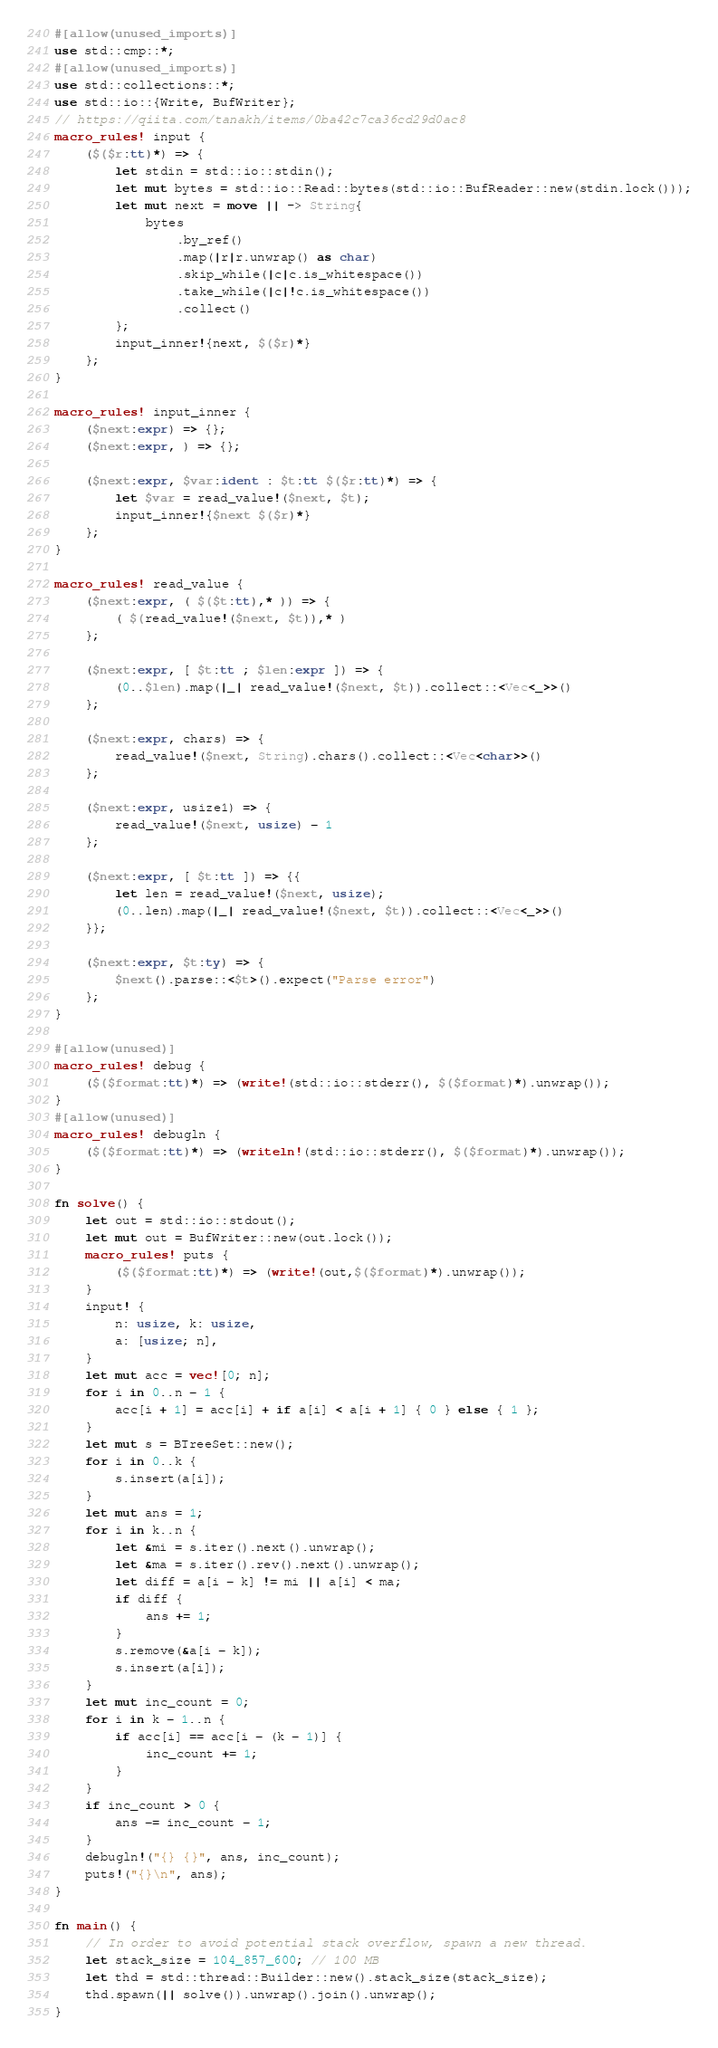Convert code to text. <code><loc_0><loc_0><loc_500><loc_500><_Rust_>#[allow(unused_imports)]
use std::cmp::*;
#[allow(unused_imports)]
use std::collections::*;
use std::io::{Write, BufWriter};
// https://qiita.com/tanakh/items/0ba42c7ca36cd29d0ac8
macro_rules! input {
    ($($r:tt)*) => {
        let stdin = std::io::stdin();
        let mut bytes = std::io::Read::bytes(std::io::BufReader::new(stdin.lock()));
        let mut next = move || -> String{
            bytes
                .by_ref()
                .map(|r|r.unwrap() as char)
                .skip_while(|c|c.is_whitespace())
                .take_while(|c|!c.is_whitespace())
                .collect()
        };
        input_inner!{next, $($r)*}
    };
}

macro_rules! input_inner {
    ($next:expr) => {};
    ($next:expr, ) => {};

    ($next:expr, $var:ident : $t:tt $($r:tt)*) => {
        let $var = read_value!($next, $t);
        input_inner!{$next $($r)*}
    };
}

macro_rules! read_value {
    ($next:expr, ( $($t:tt),* )) => {
        ( $(read_value!($next, $t)),* )
    };

    ($next:expr, [ $t:tt ; $len:expr ]) => {
        (0..$len).map(|_| read_value!($next, $t)).collect::<Vec<_>>()
    };

    ($next:expr, chars) => {
        read_value!($next, String).chars().collect::<Vec<char>>()
    };

    ($next:expr, usize1) => {
        read_value!($next, usize) - 1
    };

    ($next:expr, [ $t:tt ]) => {{
        let len = read_value!($next, usize);
        (0..len).map(|_| read_value!($next, $t)).collect::<Vec<_>>()
    }};

    ($next:expr, $t:ty) => {
        $next().parse::<$t>().expect("Parse error")
    };
}

#[allow(unused)]
macro_rules! debug {
    ($($format:tt)*) => (write!(std::io::stderr(), $($format)*).unwrap());
}
#[allow(unused)]
macro_rules! debugln {
    ($($format:tt)*) => (writeln!(std::io::stderr(), $($format)*).unwrap());
}

fn solve() {
    let out = std::io::stdout();
    let mut out = BufWriter::new(out.lock());
    macro_rules! puts {
        ($($format:tt)*) => (write!(out,$($format)*).unwrap());
    }
    input! {
        n: usize, k: usize,
        a: [usize; n],
    }
    let mut acc = vec![0; n];
    for i in 0..n - 1 {
        acc[i + 1] = acc[i] + if a[i] < a[i + 1] { 0 } else { 1 };
    }
    let mut s = BTreeSet::new();
    for i in 0..k {
        s.insert(a[i]);
    }
    let mut ans = 1;
    for i in k..n {
        let &mi = s.iter().next().unwrap();
        let &ma = s.iter().rev().next().unwrap();
        let diff = a[i - k] != mi || a[i] < ma;
        if diff {
            ans += 1;
        }
        s.remove(&a[i - k]);
        s.insert(a[i]);
    }
    let mut inc_count = 0;
    for i in k - 1..n {
        if acc[i] == acc[i - (k - 1)] {
            inc_count += 1;
        }
    }
    if inc_count > 0 {
        ans -= inc_count - 1;
    }
    debugln!("{} {}", ans, inc_count);
    puts!("{}\n", ans);
}

fn main() {
    // In order to avoid potential stack overflow, spawn a new thread.
    let stack_size = 104_857_600; // 100 MB
    let thd = std::thread::Builder::new().stack_size(stack_size);
    thd.spawn(|| solve()).unwrap().join().unwrap();
}
</code> 